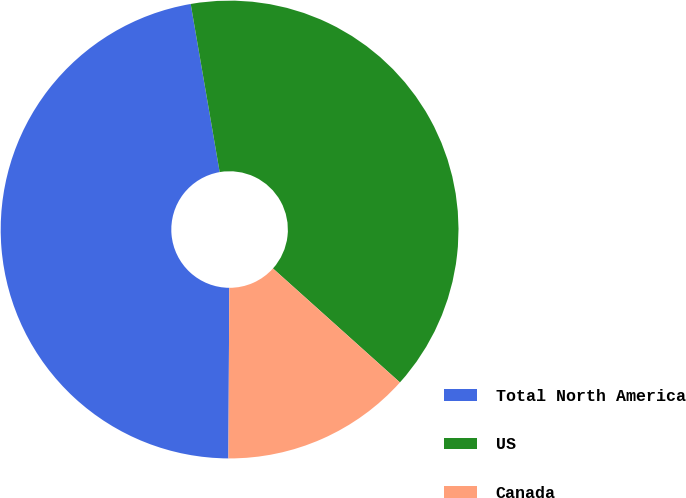<chart> <loc_0><loc_0><loc_500><loc_500><pie_chart><fcel>Total North America<fcel>US<fcel>Canada<nl><fcel>47.2%<fcel>39.36%<fcel>13.44%<nl></chart> 